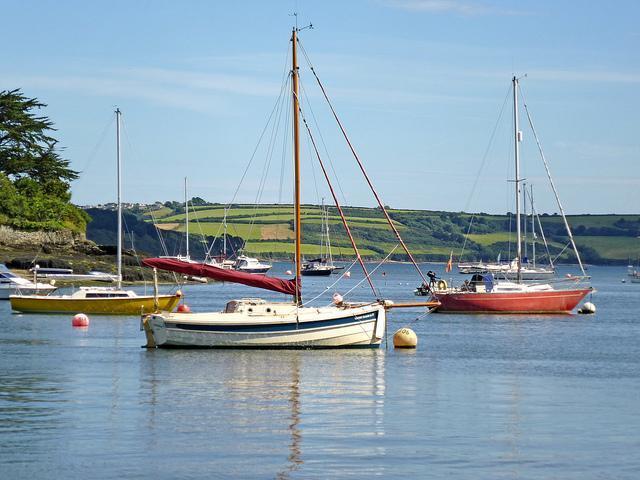How many boats are there?
Give a very brief answer. 3. How many white bears are in this scene?
Give a very brief answer. 0. 